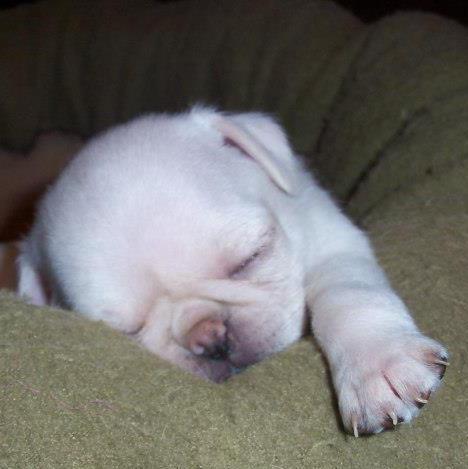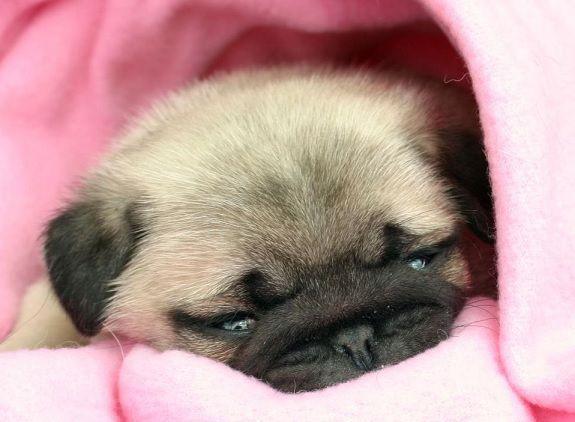The first image is the image on the left, the second image is the image on the right. Examine the images to the left and right. Is the description "puppies are sleeping on their back" accurate? Answer yes or no. No. 